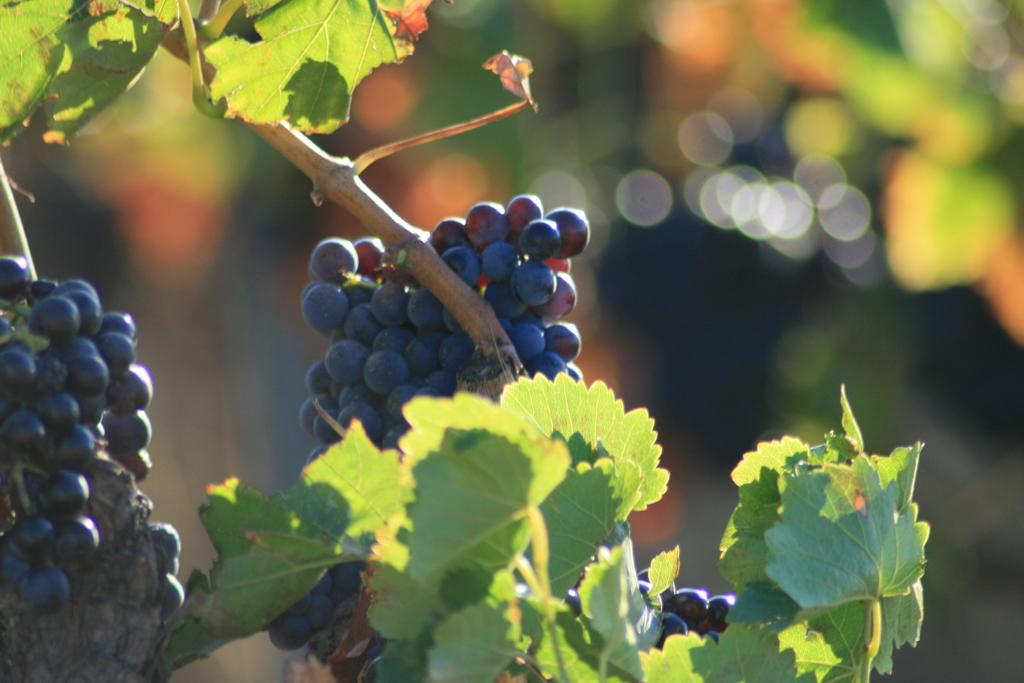What is the main subject of the image? The main subject of the image is a stem with leaves and grapes. Can you describe the grapes in the image? Yes, there are grapes on the stem in the image. What can be said about the background of the image? The background of the image is not clear. What type of bird can be seen perched on the grapes in the image? There is no bird present in the image; it only features a stem with leaves and grapes. What kind of test is being conducted in the image? There is no test being conducted in the image; it is a still image of a stem with leaves and grapes. 